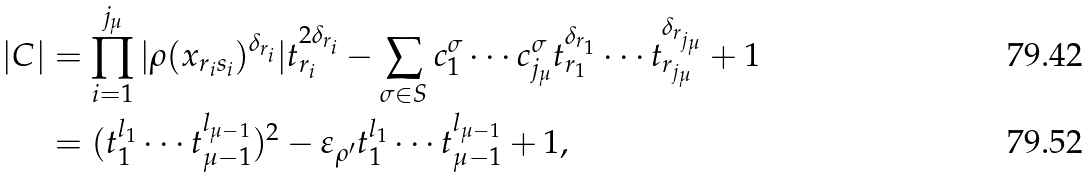<formula> <loc_0><loc_0><loc_500><loc_500>| C | & = \prod _ { i = 1 } ^ { j _ { \mu } } | \rho ( x _ { r _ { i } s _ { i } } ) ^ { \delta _ { r _ { i } } } | t _ { r _ { i } } ^ { 2 \delta _ { r _ { i } } } - \sum _ { \sigma \in S } c _ { 1 } ^ { \sigma } \cdots c _ { j _ { \mu } } ^ { \sigma } t _ { r _ { 1 } } ^ { \delta _ { r _ { 1 } } } \cdots t _ { r _ { j _ { \mu } } } ^ { \delta _ { r _ { j _ { \mu } } } } + 1 \\ & = ( t _ { 1 } ^ { l _ { 1 } } \cdots t _ { \mu - 1 } ^ { l _ { \mu - 1 } } ) ^ { 2 } - \varepsilon _ { \rho ^ { \prime } } t _ { 1 } ^ { l _ { 1 } } \cdots t _ { \mu - 1 } ^ { l _ { \mu - 1 } } + 1 ,</formula> 